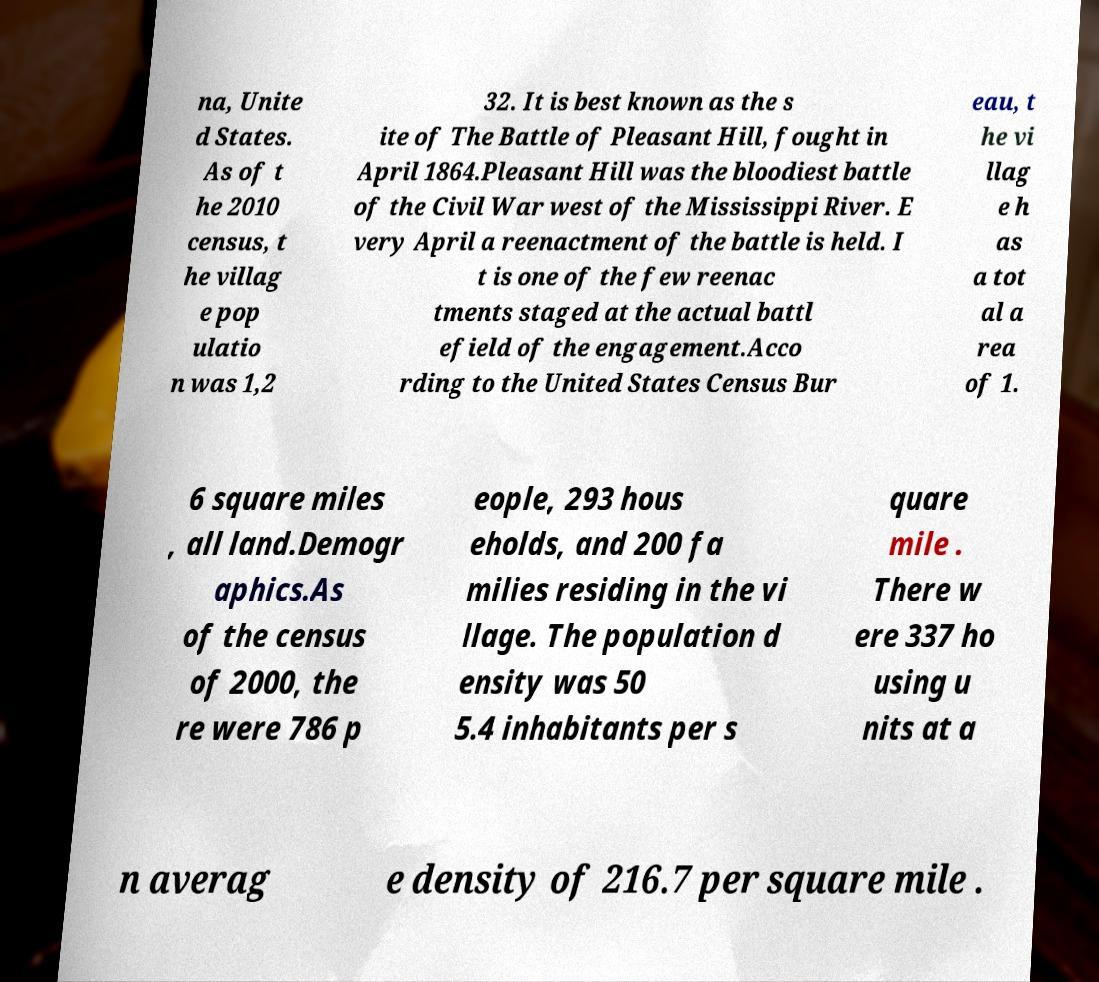Please read and relay the text visible in this image. What does it say? na, Unite d States. As of t he 2010 census, t he villag e pop ulatio n was 1,2 32. It is best known as the s ite of The Battle of Pleasant Hill, fought in April 1864.Pleasant Hill was the bloodiest battle of the Civil War west of the Mississippi River. E very April a reenactment of the battle is held. I t is one of the few reenac tments staged at the actual battl efield of the engagement.Acco rding to the United States Census Bur eau, t he vi llag e h as a tot al a rea of 1. 6 square miles , all land.Demogr aphics.As of the census of 2000, the re were 786 p eople, 293 hous eholds, and 200 fa milies residing in the vi llage. The population d ensity was 50 5.4 inhabitants per s quare mile . There w ere 337 ho using u nits at a n averag e density of 216.7 per square mile . 